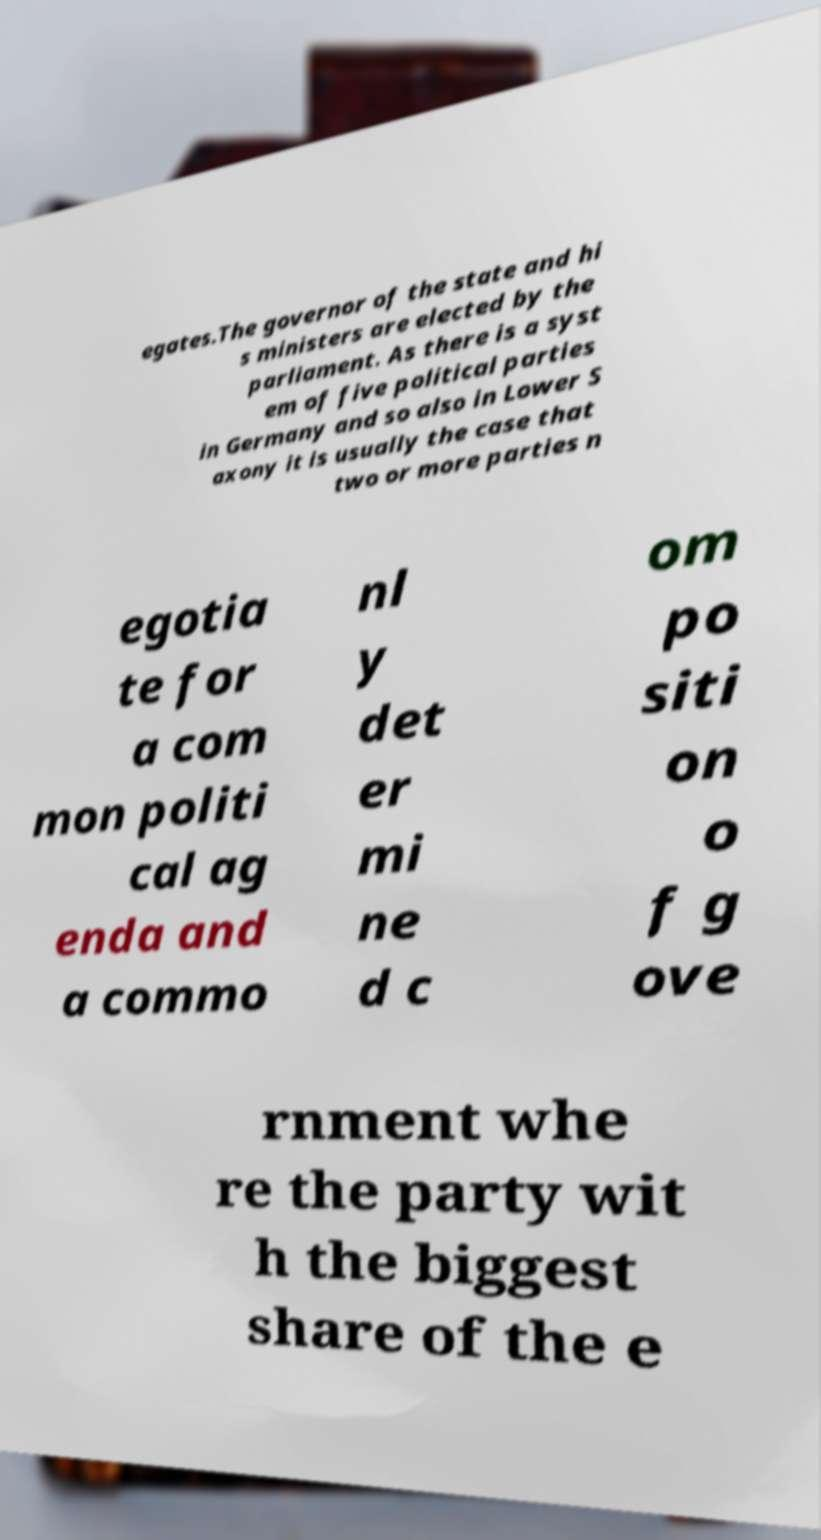Can you read and provide the text displayed in the image?This photo seems to have some interesting text. Can you extract and type it out for me? egates.The governor of the state and hi s ministers are elected by the parliament. As there is a syst em of five political parties in Germany and so also in Lower S axony it is usually the case that two or more parties n egotia te for a com mon politi cal ag enda and a commo nl y det er mi ne d c om po siti on o f g ove rnment whe re the party wit h the biggest share of the e 